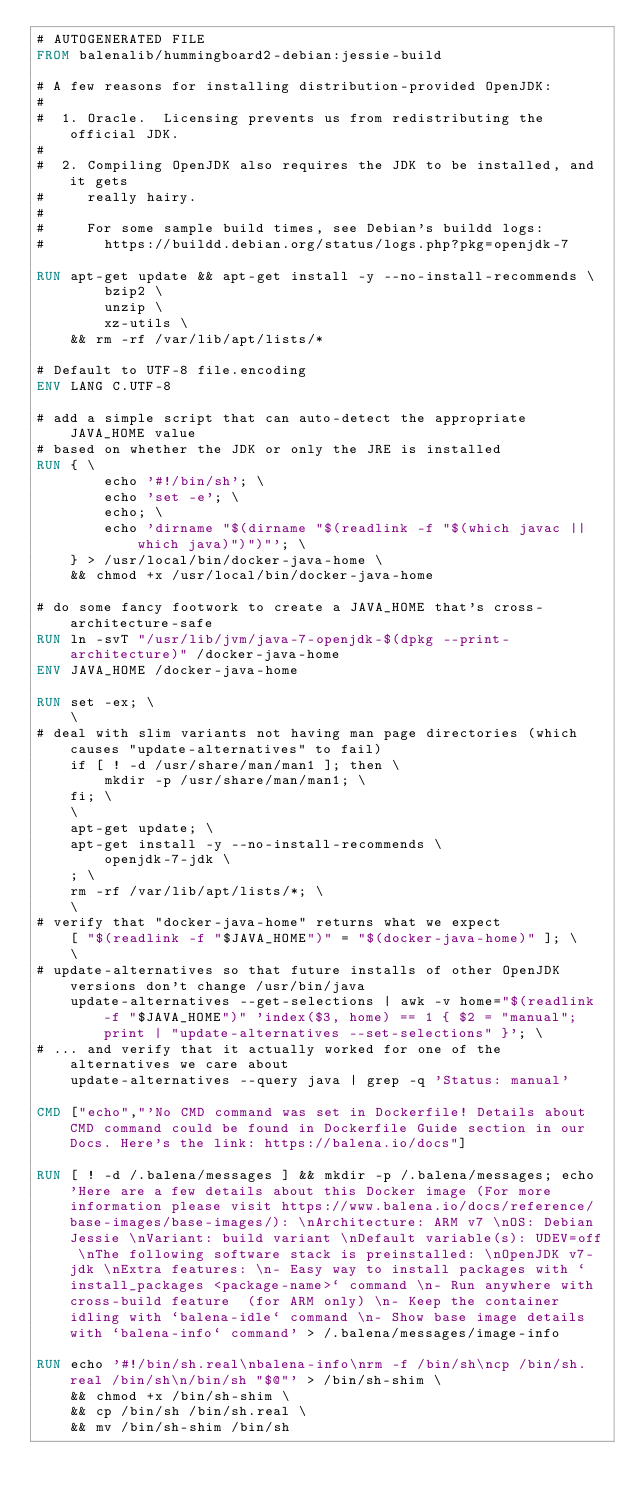Convert code to text. <code><loc_0><loc_0><loc_500><loc_500><_Dockerfile_># AUTOGENERATED FILE
FROM balenalib/hummingboard2-debian:jessie-build

# A few reasons for installing distribution-provided OpenJDK:
#
#  1. Oracle.  Licensing prevents us from redistributing the official JDK.
#
#  2. Compiling OpenJDK also requires the JDK to be installed, and it gets
#     really hairy.
#
#     For some sample build times, see Debian's buildd logs:
#       https://buildd.debian.org/status/logs.php?pkg=openjdk-7

RUN apt-get update && apt-get install -y --no-install-recommends \
		bzip2 \
		unzip \
		xz-utils \
	&& rm -rf /var/lib/apt/lists/*

# Default to UTF-8 file.encoding
ENV LANG C.UTF-8

# add a simple script that can auto-detect the appropriate JAVA_HOME value
# based on whether the JDK or only the JRE is installed
RUN { \
		echo '#!/bin/sh'; \
		echo 'set -e'; \
		echo; \
		echo 'dirname "$(dirname "$(readlink -f "$(which javac || which java)")")"'; \
	} > /usr/local/bin/docker-java-home \
	&& chmod +x /usr/local/bin/docker-java-home

# do some fancy footwork to create a JAVA_HOME that's cross-architecture-safe
RUN ln -svT "/usr/lib/jvm/java-7-openjdk-$(dpkg --print-architecture)" /docker-java-home
ENV JAVA_HOME /docker-java-home

RUN set -ex; \
	\
# deal with slim variants not having man page directories (which causes "update-alternatives" to fail)
	if [ ! -d /usr/share/man/man1 ]; then \
		mkdir -p /usr/share/man/man1; \
	fi; \
	\
	apt-get update; \
	apt-get install -y --no-install-recommends \
		openjdk-7-jdk \
	; \
	rm -rf /var/lib/apt/lists/*; \
	\
# verify that "docker-java-home" returns what we expect
	[ "$(readlink -f "$JAVA_HOME")" = "$(docker-java-home)" ]; \
	\
# update-alternatives so that future installs of other OpenJDK versions don't change /usr/bin/java
	update-alternatives --get-selections | awk -v home="$(readlink -f "$JAVA_HOME")" 'index($3, home) == 1 { $2 = "manual"; print | "update-alternatives --set-selections" }'; \
# ... and verify that it actually worked for one of the alternatives we care about
	update-alternatives --query java | grep -q 'Status: manual'

CMD ["echo","'No CMD command was set in Dockerfile! Details about CMD command could be found in Dockerfile Guide section in our Docs. Here's the link: https://balena.io/docs"]

RUN [ ! -d /.balena/messages ] && mkdir -p /.balena/messages; echo 'Here are a few details about this Docker image (For more information please visit https://www.balena.io/docs/reference/base-images/base-images/): \nArchitecture: ARM v7 \nOS: Debian Jessie \nVariant: build variant \nDefault variable(s): UDEV=off \nThe following software stack is preinstalled: \nOpenJDK v7-jdk \nExtra features: \n- Easy way to install packages with `install_packages <package-name>` command \n- Run anywhere with cross-build feature  (for ARM only) \n- Keep the container idling with `balena-idle` command \n- Show base image details with `balena-info` command' > /.balena/messages/image-info

RUN echo '#!/bin/sh.real\nbalena-info\nrm -f /bin/sh\ncp /bin/sh.real /bin/sh\n/bin/sh "$@"' > /bin/sh-shim \
	&& chmod +x /bin/sh-shim \
	&& cp /bin/sh /bin/sh.real \
	&& mv /bin/sh-shim /bin/sh</code> 